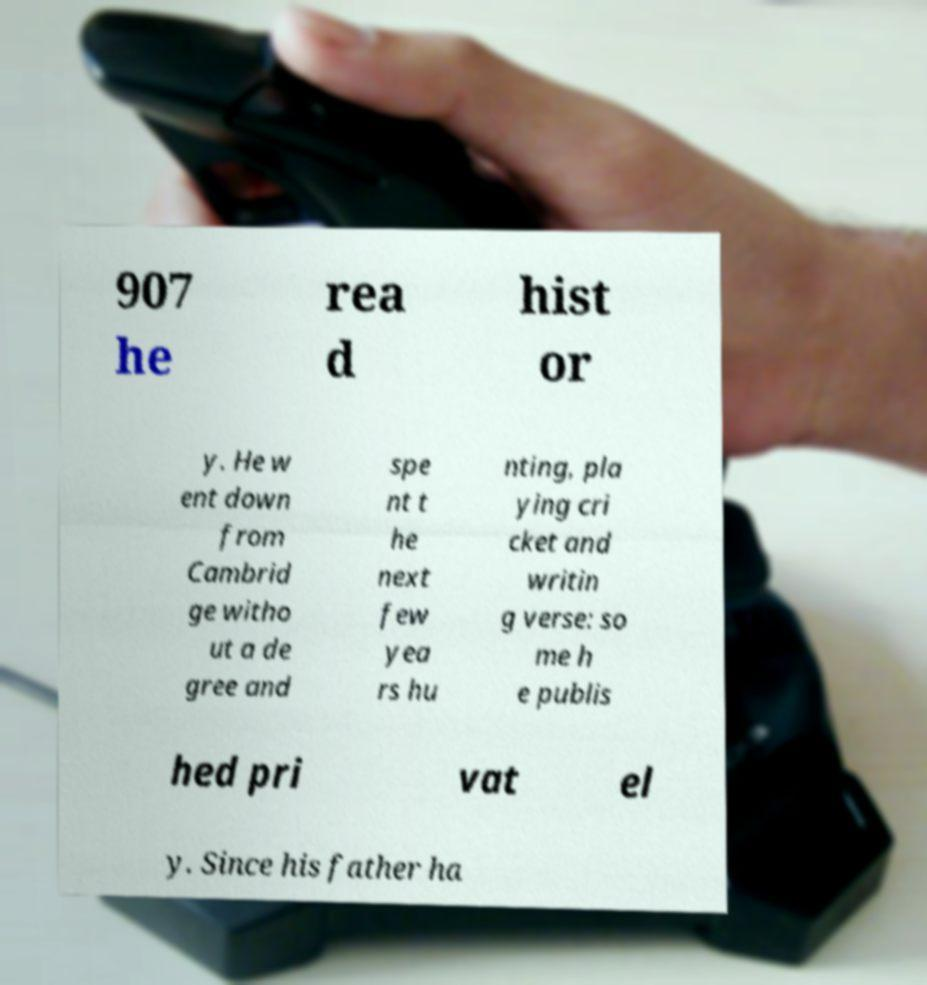Can you accurately transcribe the text from the provided image for me? 907 he rea d hist or y. He w ent down from Cambrid ge witho ut a de gree and spe nt t he next few yea rs hu nting, pla ying cri cket and writin g verse: so me h e publis hed pri vat el y. Since his father ha 